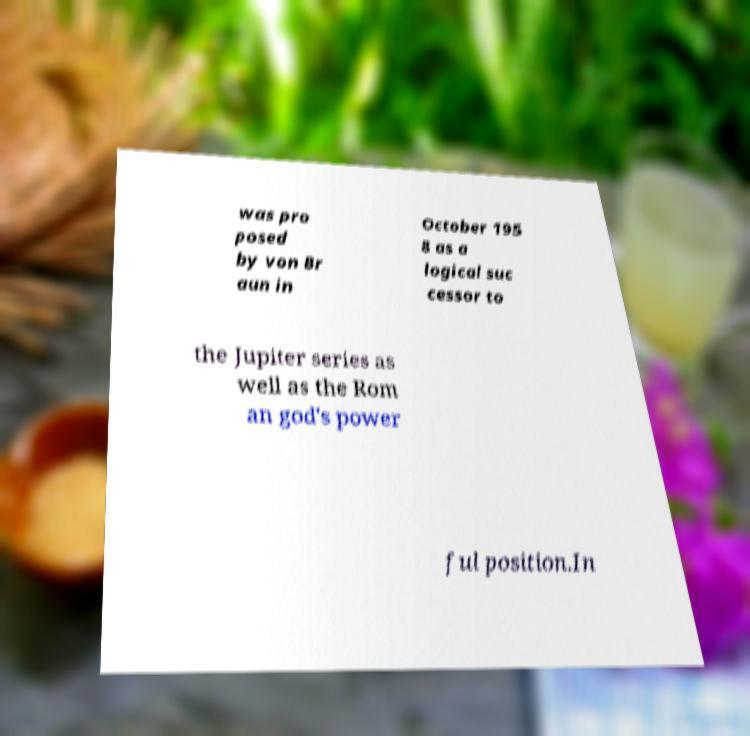For documentation purposes, I need the text within this image transcribed. Could you provide that? was pro posed by von Br aun in October 195 8 as a logical suc cessor to the Jupiter series as well as the Rom an god's power ful position.In 